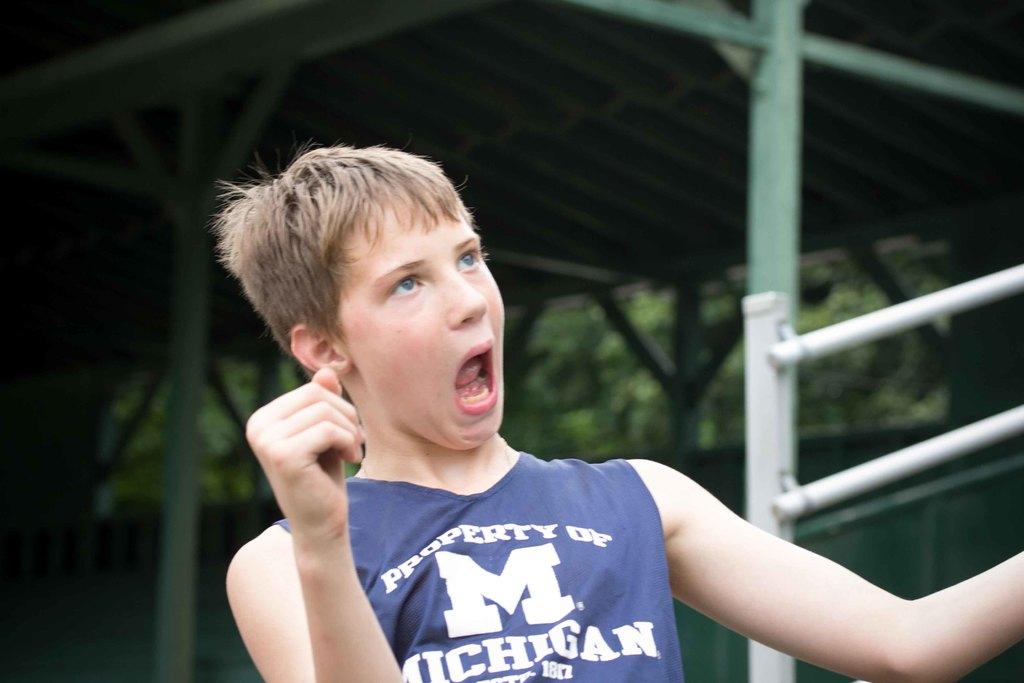What state is on his shirt?
Your answer should be compact. Michigan. 